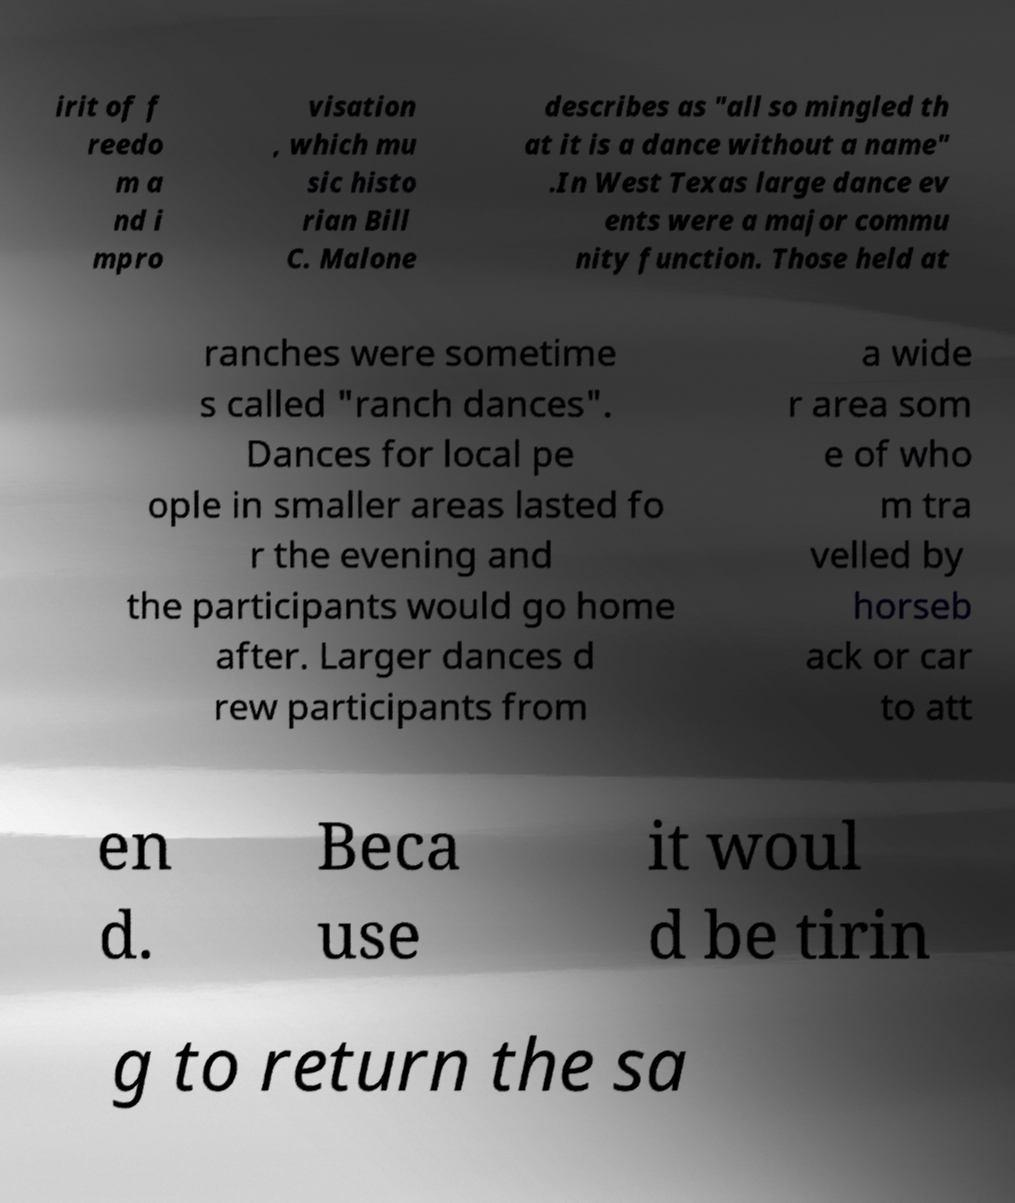Can you read and provide the text displayed in the image?This photo seems to have some interesting text. Can you extract and type it out for me? irit of f reedo m a nd i mpro visation , which mu sic histo rian Bill C. Malone describes as "all so mingled th at it is a dance without a name" .In West Texas large dance ev ents were a major commu nity function. Those held at ranches were sometime s called "ranch dances". Dances for local pe ople in smaller areas lasted fo r the evening and the participants would go home after. Larger dances d rew participants from a wide r area som e of who m tra velled by horseb ack or car to att en d. Beca use it woul d be tirin g to return the sa 